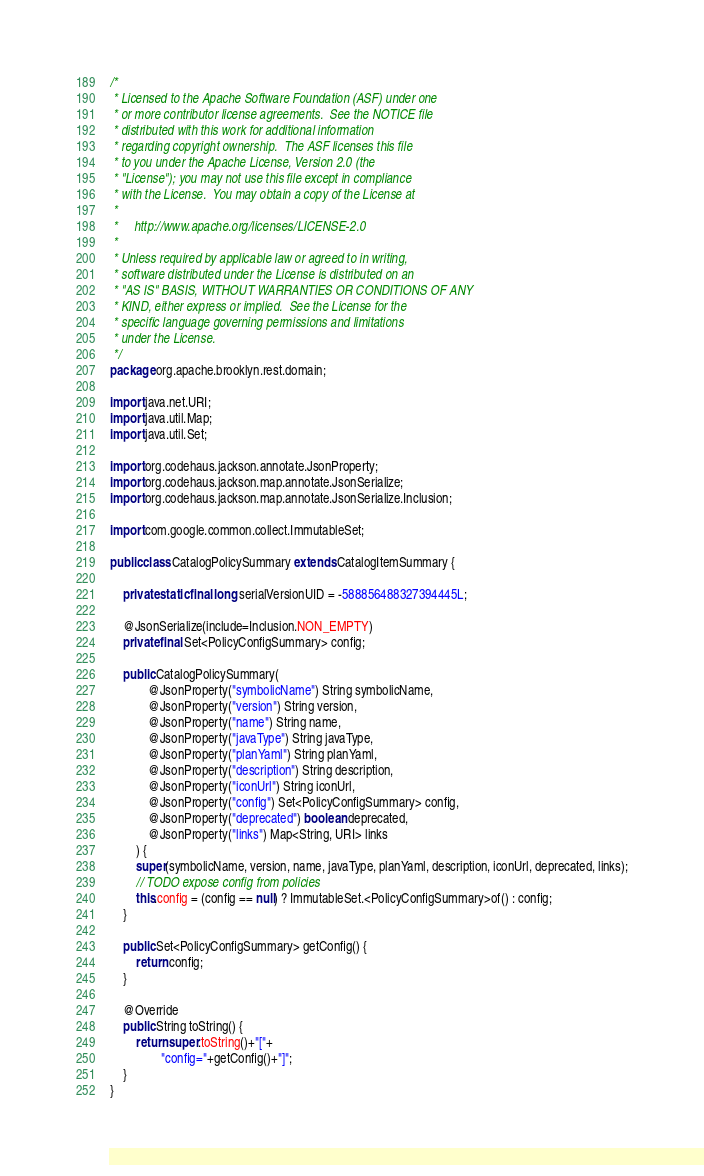Convert code to text. <code><loc_0><loc_0><loc_500><loc_500><_Java_>/*
 * Licensed to the Apache Software Foundation (ASF) under one
 * or more contributor license agreements.  See the NOTICE file
 * distributed with this work for additional information
 * regarding copyright ownership.  The ASF licenses this file
 * to you under the Apache License, Version 2.0 (the
 * "License"); you may not use this file except in compliance
 * with the License.  You may obtain a copy of the License at
 *
 *     http://www.apache.org/licenses/LICENSE-2.0
 *
 * Unless required by applicable law or agreed to in writing,
 * software distributed under the License is distributed on an
 * "AS IS" BASIS, WITHOUT WARRANTIES OR CONDITIONS OF ANY
 * KIND, either express or implied.  See the License for the
 * specific language governing permissions and limitations
 * under the License.
 */
package org.apache.brooklyn.rest.domain;

import java.net.URI;
import java.util.Map;
import java.util.Set;

import org.codehaus.jackson.annotate.JsonProperty;
import org.codehaus.jackson.map.annotate.JsonSerialize;
import org.codehaus.jackson.map.annotate.JsonSerialize.Inclusion;

import com.google.common.collect.ImmutableSet;

public class CatalogPolicySummary extends CatalogItemSummary {

    private static final long serialVersionUID = -588856488327394445L;
    
    @JsonSerialize(include=Inclusion.NON_EMPTY)
    private final Set<PolicyConfigSummary> config;

    public CatalogPolicySummary(
            @JsonProperty("symbolicName") String symbolicName,
            @JsonProperty("version") String version,
            @JsonProperty("name") String name,
            @JsonProperty("javaType") String javaType,
            @JsonProperty("planYaml") String planYaml,
            @JsonProperty("description") String description,
            @JsonProperty("iconUrl") String iconUrl,
            @JsonProperty("config") Set<PolicyConfigSummary> config,
            @JsonProperty("deprecated") boolean deprecated,
            @JsonProperty("links") Map<String, URI> links
        ) {
        super(symbolicName, version, name, javaType, planYaml, description, iconUrl, deprecated, links);
        // TODO expose config from policies
        this.config = (config == null) ? ImmutableSet.<PolicyConfigSummary>of() : config;
    }
    
    public Set<PolicyConfigSummary> getConfig() {
        return config;
    }

    @Override
    public String toString() {
        return super.toString()+"["+
                "config="+getConfig()+"]";
    }
}
</code> 